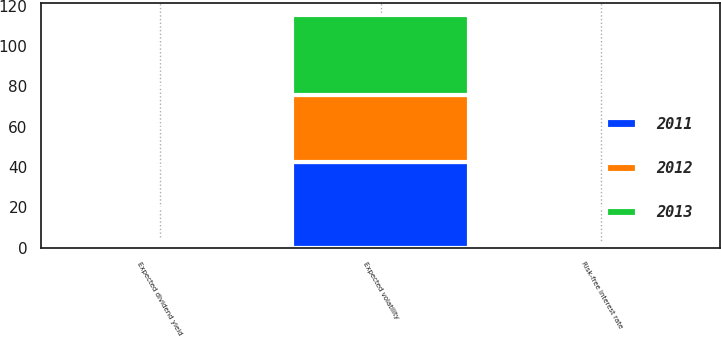Convert chart to OTSL. <chart><loc_0><loc_0><loc_500><loc_500><stacked_bar_chart><ecel><fcel>Risk-free interest rate<fcel>Expected dividend yield<fcel>Expected volatility<nl><fcel>2012<fcel>0.3<fcel>1.5<fcel>33.7<nl><fcel>2013<fcel>0.4<fcel>1.3<fcel>39.7<nl><fcel>2011<fcel>1<fcel>0.7<fcel>42.3<nl></chart> 